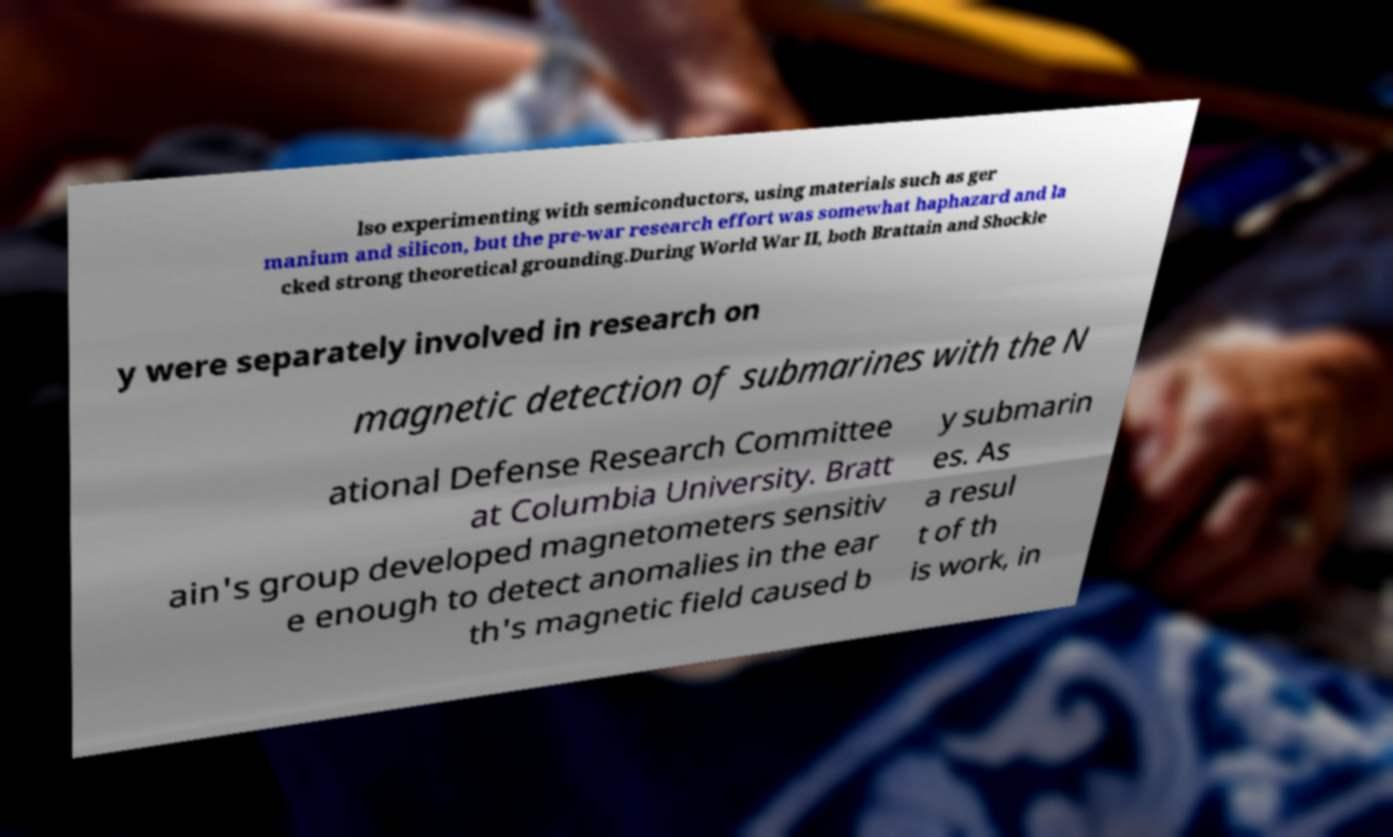For documentation purposes, I need the text within this image transcribed. Could you provide that? lso experimenting with semiconductors, using materials such as ger manium and silicon, but the pre-war research effort was somewhat haphazard and la cked strong theoretical grounding.During World War II, both Brattain and Shockle y were separately involved in research on magnetic detection of submarines with the N ational Defense Research Committee at Columbia University. Bratt ain's group developed magnetometers sensitiv e enough to detect anomalies in the ear th's magnetic field caused b y submarin es. As a resul t of th is work, in 